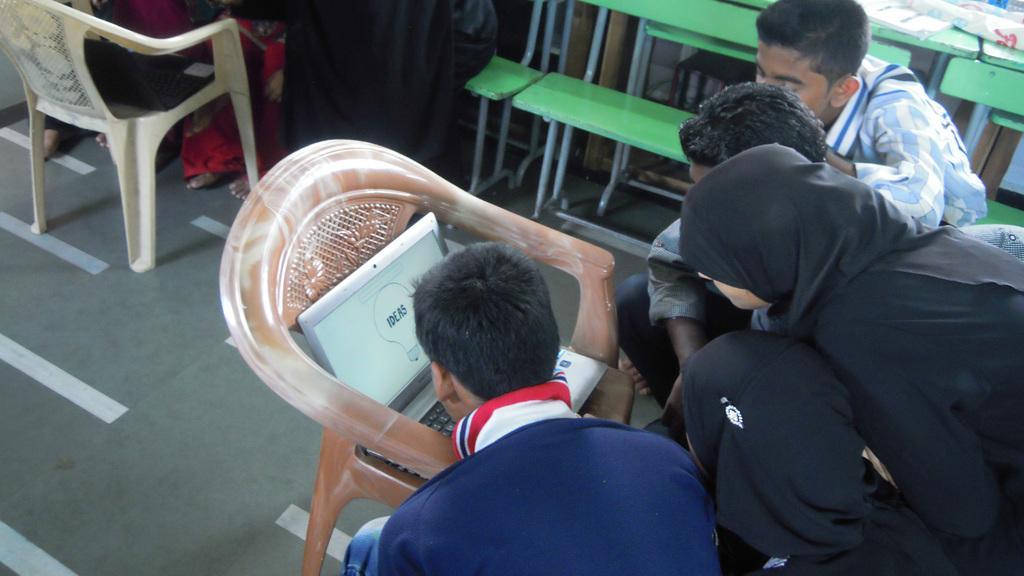Can you describe this image briefly? This picture shows few people seated and a person standing and we see a laptop on the chair and we see few benches 